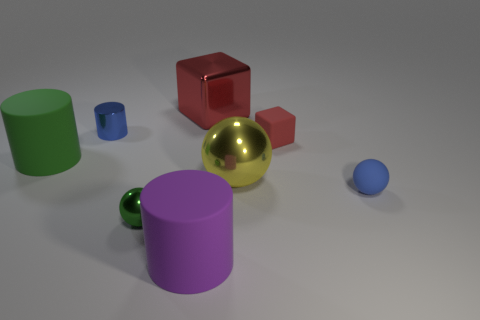What shape is the tiny red rubber object?
Your response must be concise. Cube. There is a shiny thing that is the same color as the tiny block; what size is it?
Offer a very short reply. Large. What size is the green thing that is on the right side of the blue object that is behind the yellow ball?
Provide a short and direct response. Small. There is a metallic ball behind the small green metallic sphere; how big is it?
Make the answer very short. Large. Are there fewer green matte cylinders on the right side of the small block than big yellow metallic balls left of the large yellow object?
Offer a very short reply. No. What color is the small shiny cylinder?
Give a very brief answer. Blue. Are there any big cylinders of the same color as the small rubber sphere?
Offer a terse response. No. What shape is the tiny blue object that is right of the object that is behind the shiny object that is to the left of the small green metallic thing?
Ensure brevity in your answer.  Sphere. What is the blue object that is left of the big block made of?
Your answer should be compact. Metal. What size is the matte cylinder that is behind the big matte thing that is in front of the tiny ball that is to the right of the purple rubber object?
Offer a very short reply. Large. 